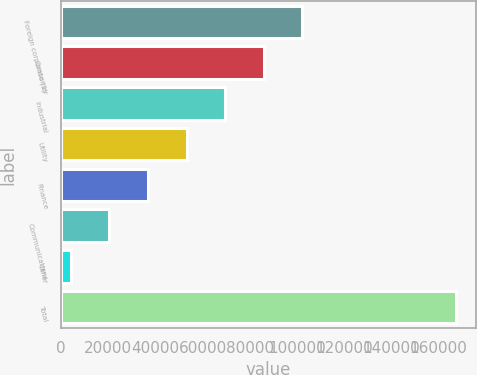Convert chart to OTSL. <chart><loc_0><loc_0><loc_500><loc_500><bar_chart><fcel>Foreign corporate (1)<fcel>Consumer<fcel>Industrial<fcel>Utility<fcel>Finance<fcel>Communications<fcel>Other<fcel>Total<nl><fcel>102232<fcel>85883<fcel>69533.8<fcel>53184.6<fcel>36835.4<fcel>20486.2<fcel>4137<fcel>167629<nl></chart> 